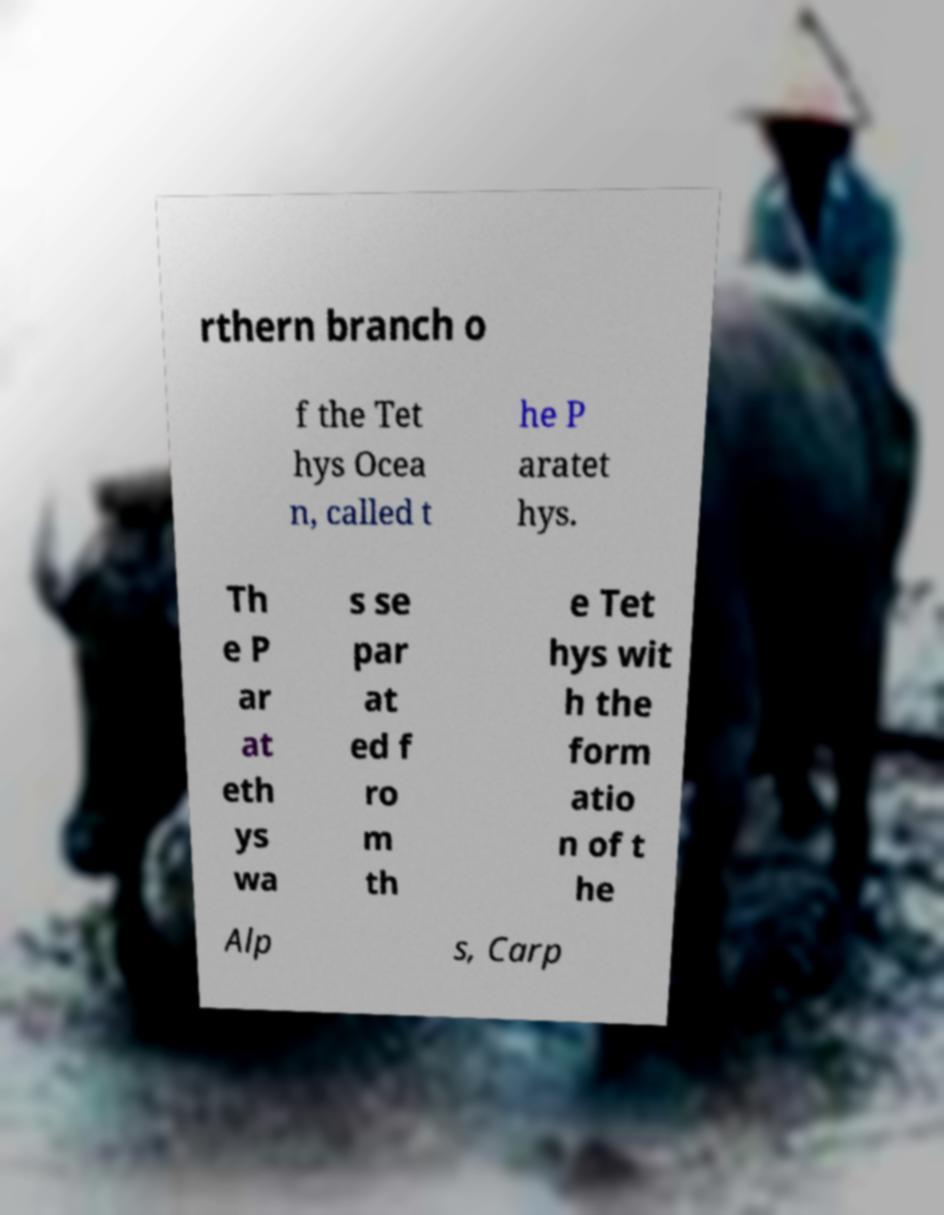What messages or text are displayed in this image? I need them in a readable, typed format. rthern branch o f the Tet hys Ocea n, called t he P aratet hys. Th e P ar at eth ys wa s se par at ed f ro m th e Tet hys wit h the form atio n of t he Alp s, Carp 